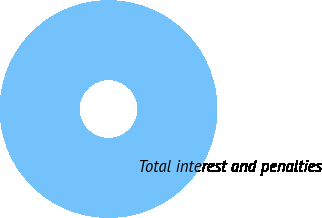<chart> <loc_0><loc_0><loc_500><loc_500><pie_chart><fcel>Total interest and penalties<nl><fcel>100.0%<nl></chart> 